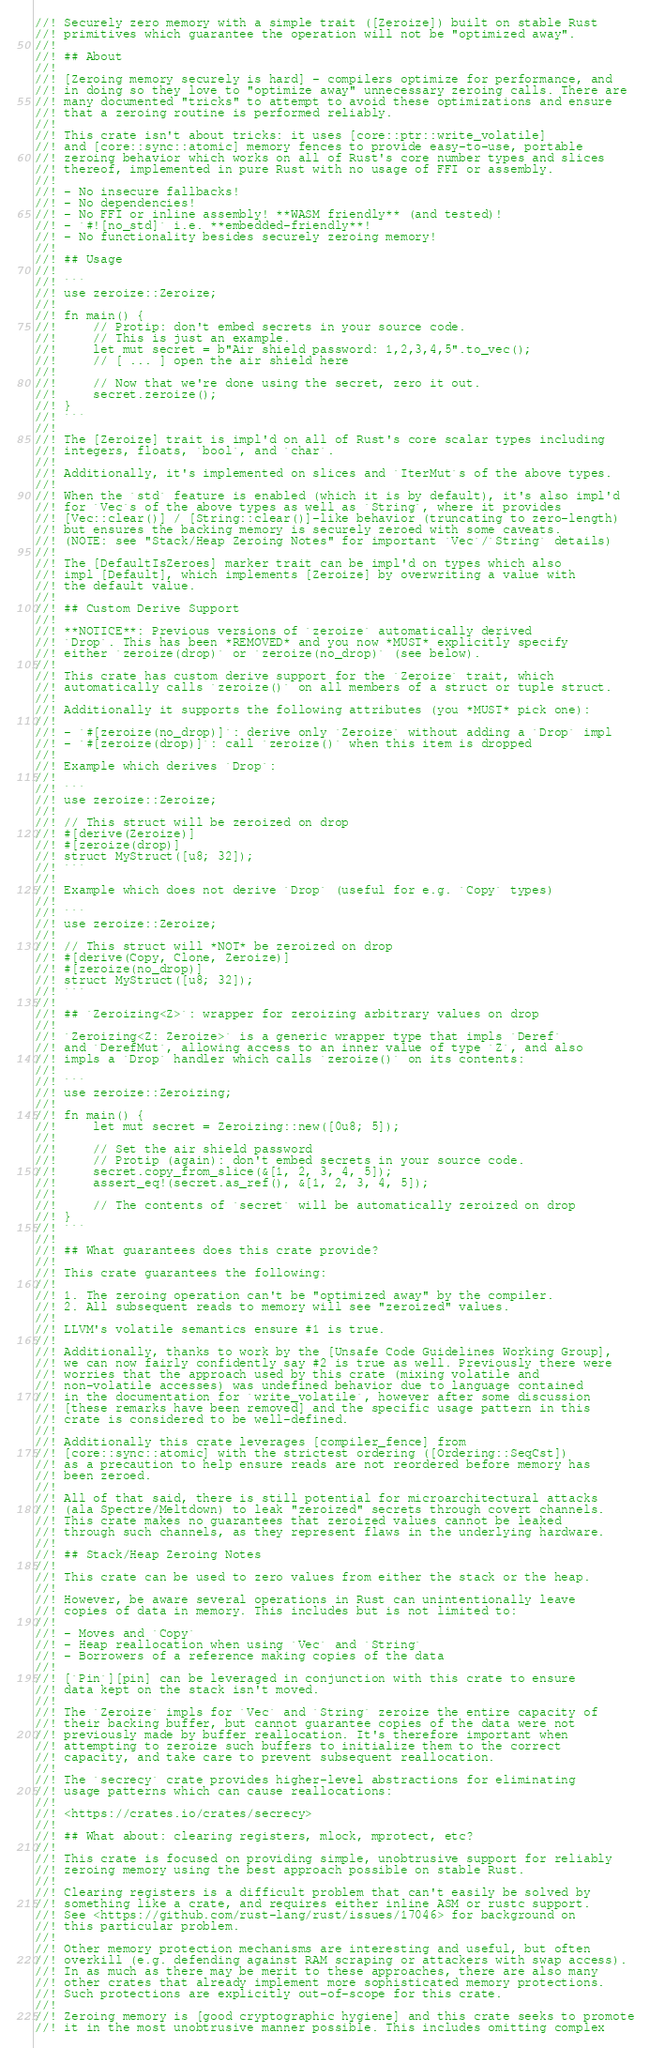Convert code to text. <code><loc_0><loc_0><loc_500><loc_500><_Rust_>//! Securely zero memory with a simple trait ([Zeroize]) built on stable Rust
//! primitives which guarantee the operation will not be "optimized away".
//!
//! ## About
//!
//! [Zeroing memory securely is hard] - compilers optimize for performance, and
//! in doing so they love to "optimize away" unnecessary zeroing calls. There are
//! many documented "tricks" to attempt to avoid these optimizations and ensure
//! that a zeroing routine is performed reliably.
//!
//! This crate isn't about tricks: it uses [core::ptr::write_volatile]
//! and [core::sync::atomic] memory fences to provide easy-to-use, portable
//! zeroing behavior which works on all of Rust's core number types and slices
//! thereof, implemented in pure Rust with no usage of FFI or assembly.
//!
//! - No insecure fallbacks!
//! - No dependencies!
//! - No FFI or inline assembly! **WASM friendly** (and tested)!
//! - `#![no_std]` i.e. **embedded-friendly**!
//! - No functionality besides securely zeroing memory!
//!
//! ## Usage
//!
//! ```
//! use zeroize::Zeroize;
//!
//! fn main() {
//!     // Protip: don't embed secrets in your source code.
//!     // This is just an example.
//!     let mut secret = b"Air shield password: 1,2,3,4,5".to_vec();
//!     // [ ... ] open the air shield here
//!
//!     // Now that we're done using the secret, zero it out.
//!     secret.zeroize();
//! }
//! ```
//!
//! The [Zeroize] trait is impl'd on all of Rust's core scalar types including
//! integers, floats, `bool`, and `char`.
//!
//! Additionally, it's implemented on slices and `IterMut`s of the above types.
//!
//! When the `std` feature is enabled (which it is by default), it's also impl'd
//! for `Vec`s of the above types as well as `String`, where it provides
//! [Vec::clear()] / [String::clear()]-like behavior (truncating to zero-length)
//! but ensures the backing memory is securely zeroed with some caveats.
//! (NOTE: see "Stack/Heap Zeroing Notes" for important `Vec`/`String` details)
//!
//! The [DefaultIsZeroes] marker trait can be impl'd on types which also
//! impl [Default], which implements [Zeroize] by overwriting a value with
//! the default value.
//!
//! ## Custom Derive Support
//!
//! **NOTICE**: Previous versions of `zeroize` automatically derived
//! `Drop`. This has been *REMOVED* and you now *MUST* explicitly specify
//! either `zeroize(drop)` or `zeroize(no_drop)` (see below).
//!
//! This crate has custom derive support for the `Zeroize` trait, which
//! automatically calls `zeroize()` on all members of a struct or tuple struct.
//!
//! Additionally it supports the following attributes (you *MUST* pick one):
//!
//! - `#[zeroize(no_drop)]`: derive only `Zeroize` without adding a `Drop` impl
//! - `#[zeroize(drop)]`: call `zeroize()` when this item is dropped
//!
//! Example which derives `Drop`:
//!
//! ```
//! use zeroize::Zeroize;
//!
//! // This struct will be zeroized on drop
//! #[derive(Zeroize)]
//! #[zeroize(drop)]
//! struct MyStruct([u8; 32]);
//! ```
//!
//! Example which does not derive `Drop` (useful for e.g. `Copy` types)
//!
//! ```
//! use zeroize::Zeroize;
//!
//! // This struct will *NOT* be zeroized on drop
//! #[derive(Copy, Clone, Zeroize)]
//! #[zeroize(no_drop)]
//! struct MyStruct([u8; 32]);
//! ```
//!
//! ## `Zeroizing<Z>`: wrapper for zeroizing arbitrary values on drop
//!
//! `Zeroizing<Z: Zeroize>` is a generic wrapper type that impls `Deref`
//! and `DerefMut`, allowing access to an inner value of type `Z`, and also
//! impls a `Drop` handler which calls `zeroize()` on its contents:
//!
//! ```
//! use zeroize::Zeroizing;
//!
//! fn main() {
//!     let mut secret = Zeroizing::new([0u8; 5]);
//!
//!     // Set the air shield password
//!     // Protip (again): don't embed secrets in your source code.
//!     secret.copy_from_slice(&[1, 2, 3, 4, 5]);
//!     assert_eq!(secret.as_ref(), &[1, 2, 3, 4, 5]);
//!
//!     // The contents of `secret` will be automatically zeroized on drop
//! }
//! ```
//!
//! ## What guarantees does this crate provide?
//!
//! This crate guarantees the following:
//!
//! 1. The zeroing operation can't be "optimized away" by the compiler.
//! 2. All subsequent reads to memory will see "zeroized" values.
//!
//! LLVM's volatile semantics ensure #1 is true.
//!
//! Additionally, thanks to work by the [Unsafe Code Guidelines Working Group],
//! we can now fairly confidently say #2 is true as well. Previously there were
//! worries that the approach used by this crate (mixing volatile and
//! non-volatile accesses) was undefined behavior due to language contained
//! in the documentation for `write_volatile`, however after some discussion
//! [these remarks have been removed] and the specific usage pattern in this
//! crate is considered to be well-defined.
//!
//! Additionally this crate leverages [compiler_fence] from
//! [core::sync::atomic] with the strictest ordering ([Ordering::SeqCst])
//! as a precaution to help ensure reads are not reordered before memory has
//! been zeroed.
//!
//! All of that said, there is still potential for microarchitectural attacks
//! (ala Spectre/Meltdown) to leak "zeroized" secrets through covert channels.
//! This crate makes no guarantees that zeroized values cannot be leaked
//! through such channels, as they represent flaws in the underlying hardware.
//!
//! ## Stack/Heap Zeroing Notes
//!
//! This crate can be used to zero values from either the stack or the heap.
//!
//! However, be aware several operations in Rust can unintentionally leave
//! copies of data in memory. This includes but is not limited to:
//!
//! - Moves and `Copy`
//! - Heap reallocation when using `Vec` and `String`
//! - Borrowers of a reference making copies of the data
//!
//! [`Pin`][pin] can be leveraged in conjunction with this crate to ensure
//! data kept on the stack isn't moved.
//!
//! The `Zeroize` impls for `Vec` and `String` zeroize the entire capacity of
//! their backing buffer, but cannot guarantee copies of the data were not
//! previously made by buffer reallocation. It's therefore important when
//! attempting to zeroize such buffers to initialize them to the correct
//! capacity, and take care to prevent subsequent reallocation.
//!
//! The `secrecy` crate provides higher-level abstractions for eliminating
//! usage patterns which can cause reallocations:
//!
//! <https://crates.io/crates/secrecy>
//!
//! ## What about: clearing registers, mlock, mprotect, etc?
//!
//! This crate is focused on providing simple, unobtrusive support for reliably
//! zeroing memory using the best approach possible on stable Rust.
//!
//! Clearing registers is a difficult problem that can't easily be solved by
//! something like a crate, and requires either inline ASM or rustc support.
//! See <https://github.com/rust-lang/rust/issues/17046> for background on
//! this particular problem.
//!
//! Other memory protection mechanisms are interesting and useful, but often
//! overkill (e.g. defending against RAM scraping or attackers with swap access).
//! In as much as there may be merit to these approaches, there are also many
//! other crates that already implement more sophisticated memory protections.
//! Such protections are explicitly out-of-scope for this crate.
//!
//! Zeroing memory is [good cryptographic hygiene] and this crate seeks to promote
//! it in the most unobtrusive manner possible. This includes omitting complex</code> 